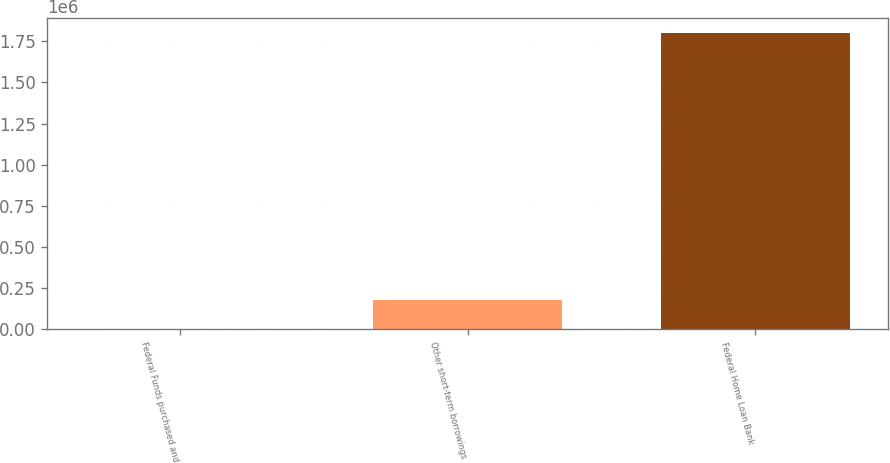Convert chart. <chart><loc_0><loc_0><loc_500><loc_500><bar_chart><fcel>Federal Funds purchased and<fcel>Other short-term borrowings<fcel>Federal Home Loan Bank<nl><fcel>0.06<fcel>180000<fcel>1.8e+06<nl></chart> 